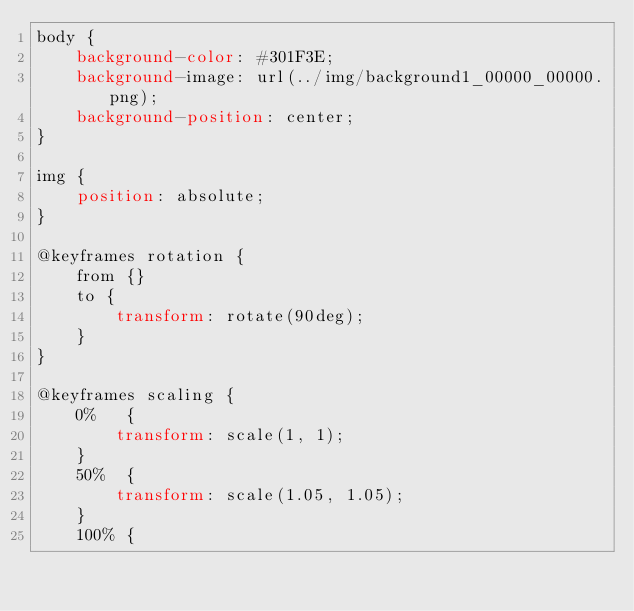<code> <loc_0><loc_0><loc_500><loc_500><_CSS_>body {
	background-color: #301F3E;
	background-image: url(../img/background1_00000_00000.png);
	background-position: center;
}

img {
	position: absolute;
}

@keyframes rotation {
	from {}
	to {
		transform: rotate(90deg);
	}
}

@keyframes scaling {
	0%   {
		transform: scale(1, 1);
	}
	50%  {
		transform: scale(1.05, 1.05);
	}
	100% {</code> 